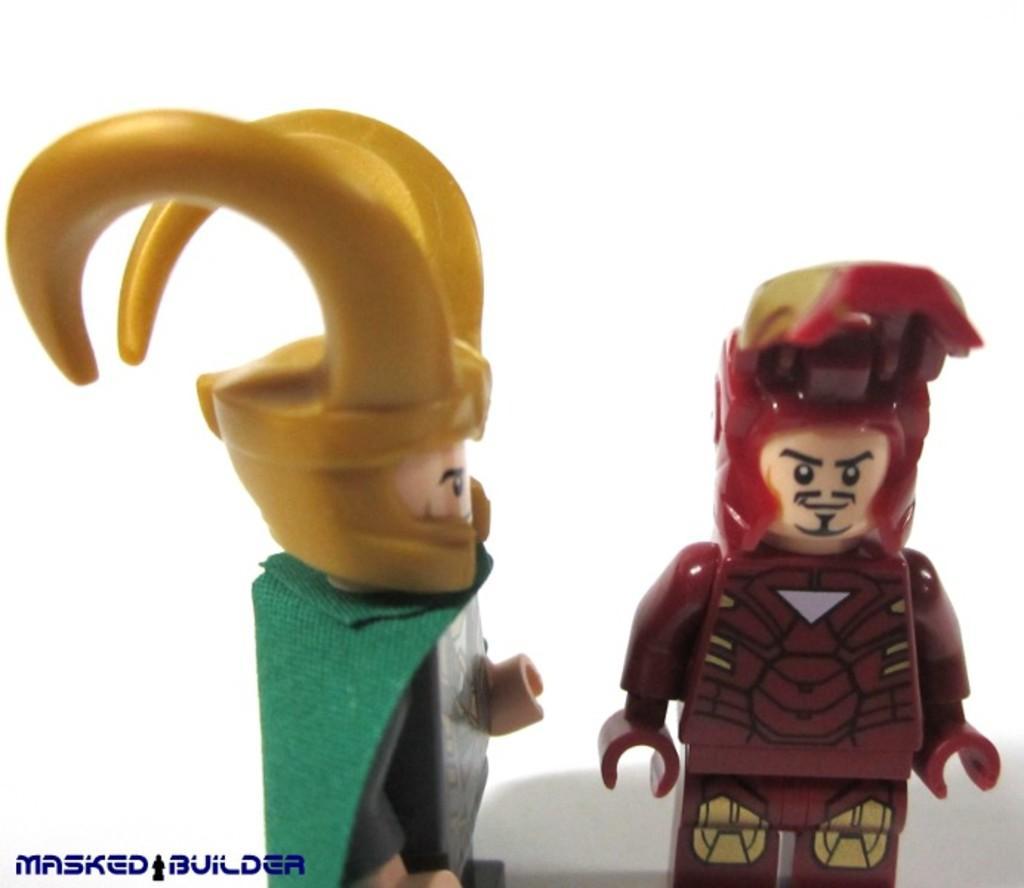How would you summarize this image in a sentence or two? In the picture we can see a two toys one toy is with a horns which are yellow in color and one toy is red in color. 